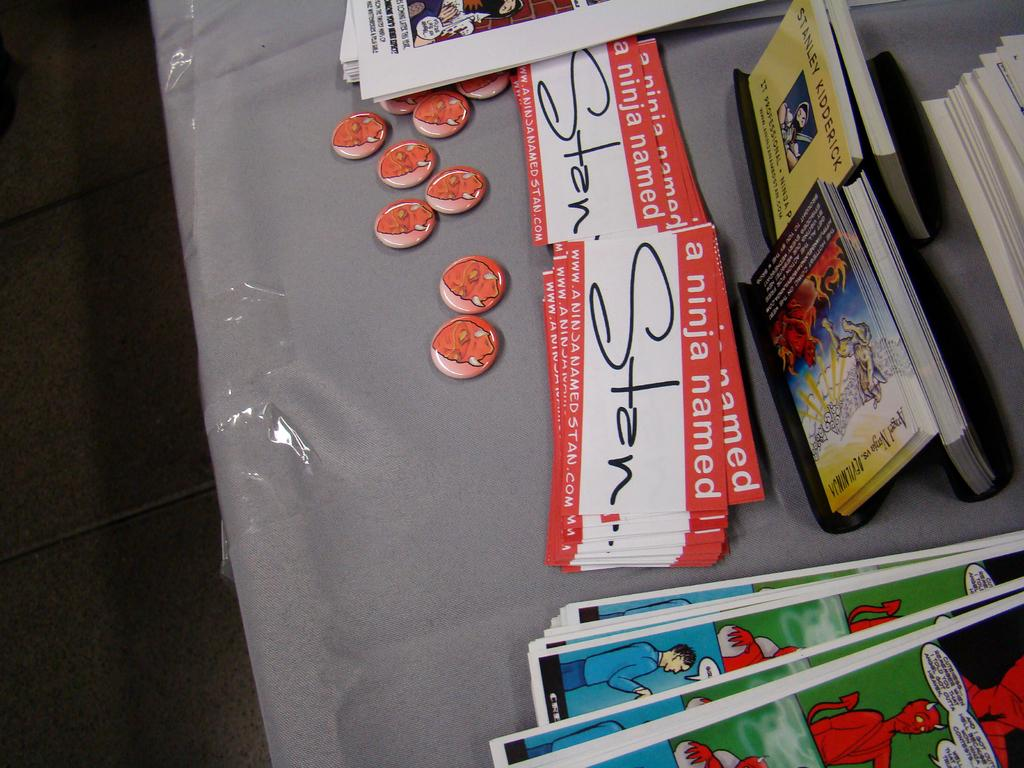<image>
Relay a brief, clear account of the picture shown. Promotional materials for a project titled A Ninja Named Stan fill a table. 